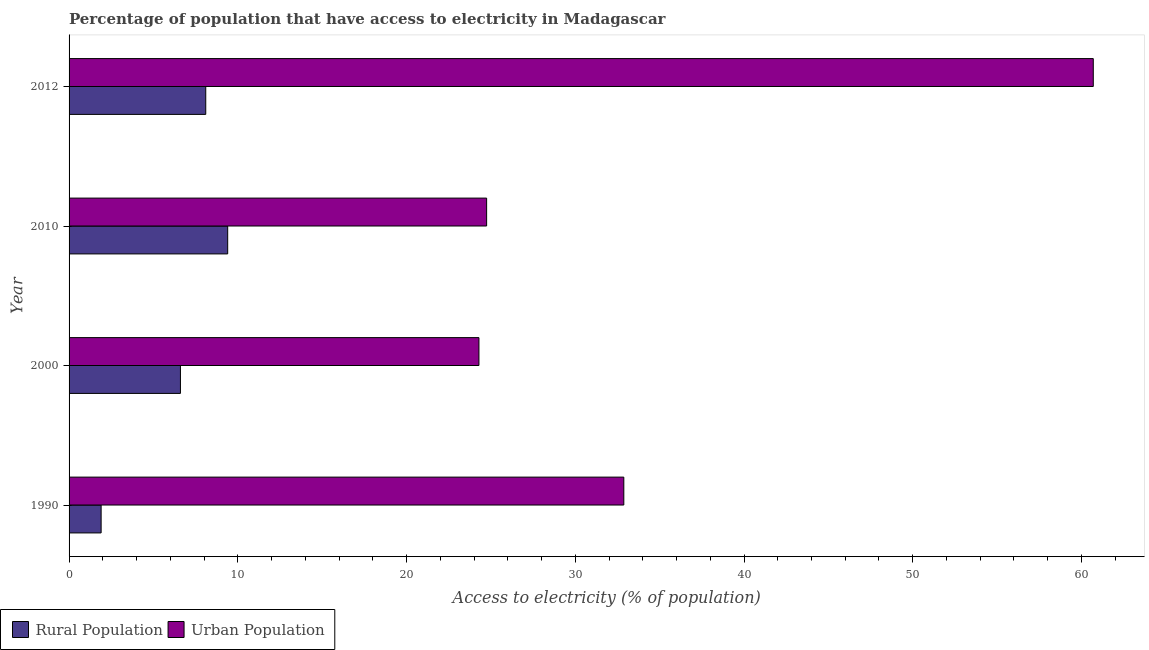Are the number of bars per tick equal to the number of legend labels?
Offer a very short reply. Yes. How many bars are there on the 1st tick from the bottom?
Offer a terse response. 2. What is the percentage of rural population having access to electricity in 2012?
Your answer should be very brief. 8.1. Across all years, what is the maximum percentage of rural population having access to electricity?
Your response must be concise. 9.4. Across all years, what is the minimum percentage of rural population having access to electricity?
Keep it short and to the point. 1.9. In which year was the percentage of rural population having access to electricity maximum?
Your response must be concise. 2010. What is the total percentage of rural population having access to electricity in the graph?
Provide a short and direct response. 26. What is the difference between the percentage of urban population having access to electricity in 2010 and that in 2012?
Offer a very short reply. -35.95. What is the difference between the percentage of rural population having access to electricity in 2000 and the percentage of urban population having access to electricity in 1990?
Your answer should be very brief. -26.28. What is the average percentage of rural population having access to electricity per year?
Your answer should be compact. 6.5. In the year 1990, what is the difference between the percentage of rural population having access to electricity and percentage of urban population having access to electricity?
Give a very brief answer. -30.98. What is the ratio of the percentage of urban population having access to electricity in 1990 to that in 2000?
Your answer should be very brief. 1.35. Is the difference between the percentage of urban population having access to electricity in 2010 and 2012 greater than the difference between the percentage of rural population having access to electricity in 2010 and 2012?
Offer a very short reply. No. What is the difference between the highest and the second highest percentage of urban population having access to electricity?
Provide a short and direct response. 27.82. What is the difference between the highest and the lowest percentage of urban population having access to electricity?
Ensure brevity in your answer.  36.41. In how many years, is the percentage of urban population having access to electricity greater than the average percentage of urban population having access to electricity taken over all years?
Give a very brief answer. 1. What does the 1st bar from the top in 2012 represents?
Offer a terse response. Urban Population. What does the 2nd bar from the bottom in 1990 represents?
Your answer should be very brief. Urban Population. What is the difference between two consecutive major ticks on the X-axis?
Your response must be concise. 10. Are the values on the major ticks of X-axis written in scientific E-notation?
Offer a terse response. No. Does the graph contain any zero values?
Keep it short and to the point. No. Where does the legend appear in the graph?
Offer a terse response. Bottom left. What is the title of the graph?
Make the answer very short. Percentage of population that have access to electricity in Madagascar. What is the label or title of the X-axis?
Ensure brevity in your answer.  Access to electricity (% of population). What is the label or title of the Y-axis?
Provide a succinct answer. Year. What is the Access to electricity (% of population) in Urban Population in 1990?
Make the answer very short. 32.88. What is the Access to electricity (% of population) in Rural Population in 2000?
Make the answer very short. 6.6. What is the Access to electricity (% of population) in Urban Population in 2000?
Offer a terse response. 24.29. What is the Access to electricity (% of population) in Urban Population in 2010?
Your answer should be very brief. 24.75. What is the Access to electricity (% of population) in Rural Population in 2012?
Provide a succinct answer. 8.1. What is the Access to electricity (% of population) in Urban Population in 2012?
Give a very brief answer. 60.7. Across all years, what is the maximum Access to electricity (% of population) of Urban Population?
Provide a succinct answer. 60.7. Across all years, what is the minimum Access to electricity (% of population) in Rural Population?
Your answer should be compact. 1.9. Across all years, what is the minimum Access to electricity (% of population) of Urban Population?
Provide a succinct answer. 24.29. What is the total Access to electricity (% of population) of Rural Population in the graph?
Your response must be concise. 26. What is the total Access to electricity (% of population) of Urban Population in the graph?
Your response must be concise. 142.61. What is the difference between the Access to electricity (% of population) in Urban Population in 1990 and that in 2000?
Your answer should be compact. 8.59. What is the difference between the Access to electricity (% of population) in Rural Population in 1990 and that in 2010?
Provide a short and direct response. -7.5. What is the difference between the Access to electricity (% of population) of Urban Population in 1990 and that in 2010?
Your answer should be compact. 8.13. What is the difference between the Access to electricity (% of population) of Urban Population in 1990 and that in 2012?
Your response must be concise. -27.82. What is the difference between the Access to electricity (% of population) of Rural Population in 2000 and that in 2010?
Offer a terse response. -2.8. What is the difference between the Access to electricity (% of population) in Urban Population in 2000 and that in 2010?
Your answer should be very brief. -0.45. What is the difference between the Access to electricity (% of population) in Urban Population in 2000 and that in 2012?
Offer a very short reply. -36.41. What is the difference between the Access to electricity (% of population) of Urban Population in 2010 and that in 2012?
Your answer should be very brief. -35.95. What is the difference between the Access to electricity (% of population) in Rural Population in 1990 and the Access to electricity (% of population) in Urban Population in 2000?
Make the answer very short. -22.39. What is the difference between the Access to electricity (% of population) of Rural Population in 1990 and the Access to electricity (% of population) of Urban Population in 2010?
Ensure brevity in your answer.  -22.85. What is the difference between the Access to electricity (% of population) of Rural Population in 1990 and the Access to electricity (% of population) of Urban Population in 2012?
Provide a succinct answer. -58.8. What is the difference between the Access to electricity (% of population) in Rural Population in 2000 and the Access to electricity (% of population) in Urban Population in 2010?
Your answer should be very brief. -18.15. What is the difference between the Access to electricity (% of population) of Rural Population in 2000 and the Access to electricity (% of population) of Urban Population in 2012?
Keep it short and to the point. -54.1. What is the difference between the Access to electricity (% of population) of Rural Population in 2010 and the Access to electricity (% of population) of Urban Population in 2012?
Give a very brief answer. -51.3. What is the average Access to electricity (% of population) in Urban Population per year?
Keep it short and to the point. 35.65. In the year 1990, what is the difference between the Access to electricity (% of population) in Rural Population and Access to electricity (% of population) in Urban Population?
Offer a terse response. -30.98. In the year 2000, what is the difference between the Access to electricity (% of population) of Rural Population and Access to electricity (% of population) of Urban Population?
Keep it short and to the point. -17.69. In the year 2010, what is the difference between the Access to electricity (% of population) in Rural Population and Access to electricity (% of population) in Urban Population?
Ensure brevity in your answer.  -15.35. In the year 2012, what is the difference between the Access to electricity (% of population) of Rural Population and Access to electricity (% of population) of Urban Population?
Keep it short and to the point. -52.6. What is the ratio of the Access to electricity (% of population) in Rural Population in 1990 to that in 2000?
Provide a short and direct response. 0.29. What is the ratio of the Access to electricity (% of population) in Urban Population in 1990 to that in 2000?
Provide a short and direct response. 1.35. What is the ratio of the Access to electricity (% of population) in Rural Population in 1990 to that in 2010?
Give a very brief answer. 0.2. What is the ratio of the Access to electricity (% of population) in Urban Population in 1990 to that in 2010?
Give a very brief answer. 1.33. What is the ratio of the Access to electricity (% of population) of Rural Population in 1990 to that in 2012?
Provide a short and direct response. 0.23. What is the ratio of the Access to electricity (% of population) of Urban Population in 1990 to that in 2012?
Keep it short and to the point. 0.54. What is the ratio of the Access to electricity (% of population) in Rural Population in 2000 to that in 2010?
Your answer should be very brief. 0.7. What is the ratio of the Access to electricity (% of population) in Urban Population in 2000 to that in 2010?
Give a very brief answer. 0.98. What is the ratio of the Access to electricity (% of population) of Rural Population in 2000 to that in 2012?
Your answer should be compact. 0.81. What is the ratio of the Access to electricity (% of population) of Urban Population in 2000 to that in 2012?
Give a very brief answer. 0.4. What is the ratio of the Access to electricity (% of population) in Rural Population in 2010 to that in 2012?
Keep it short and to the point. 1.16. What is the ratio of the Access to electricity (% of population) in Urban Population in 2010 to that in 2012?
Keep it short and to the point. 0.41. What is the difference between the highest and the second highest Access to electricity (% of population) in Urban Population?
Your answer should be very brief. 27.82. What is the difference between the highest and the lowest Access to electricity (% of population) in Urban Population?
Make the answer very short. 36.41. 